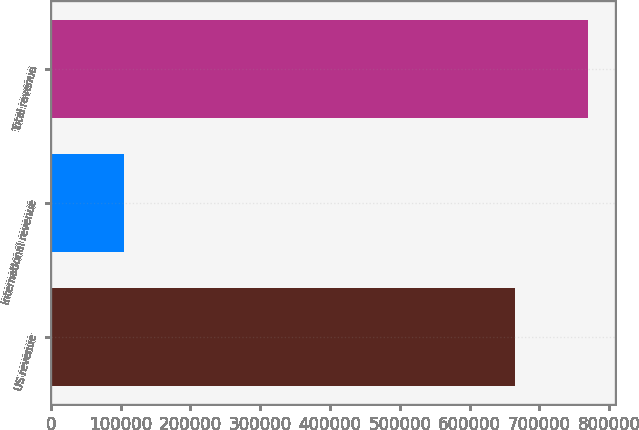Convert chart to OTSL. <chart><loc_0><loc_0><loc_500><loc_500><bar_chart><fcel>US revenue<fcel>International revenue<fcel>Total revenue<nl><fcel>665082<fcel>104350<fcel>769432<nl></chart> 